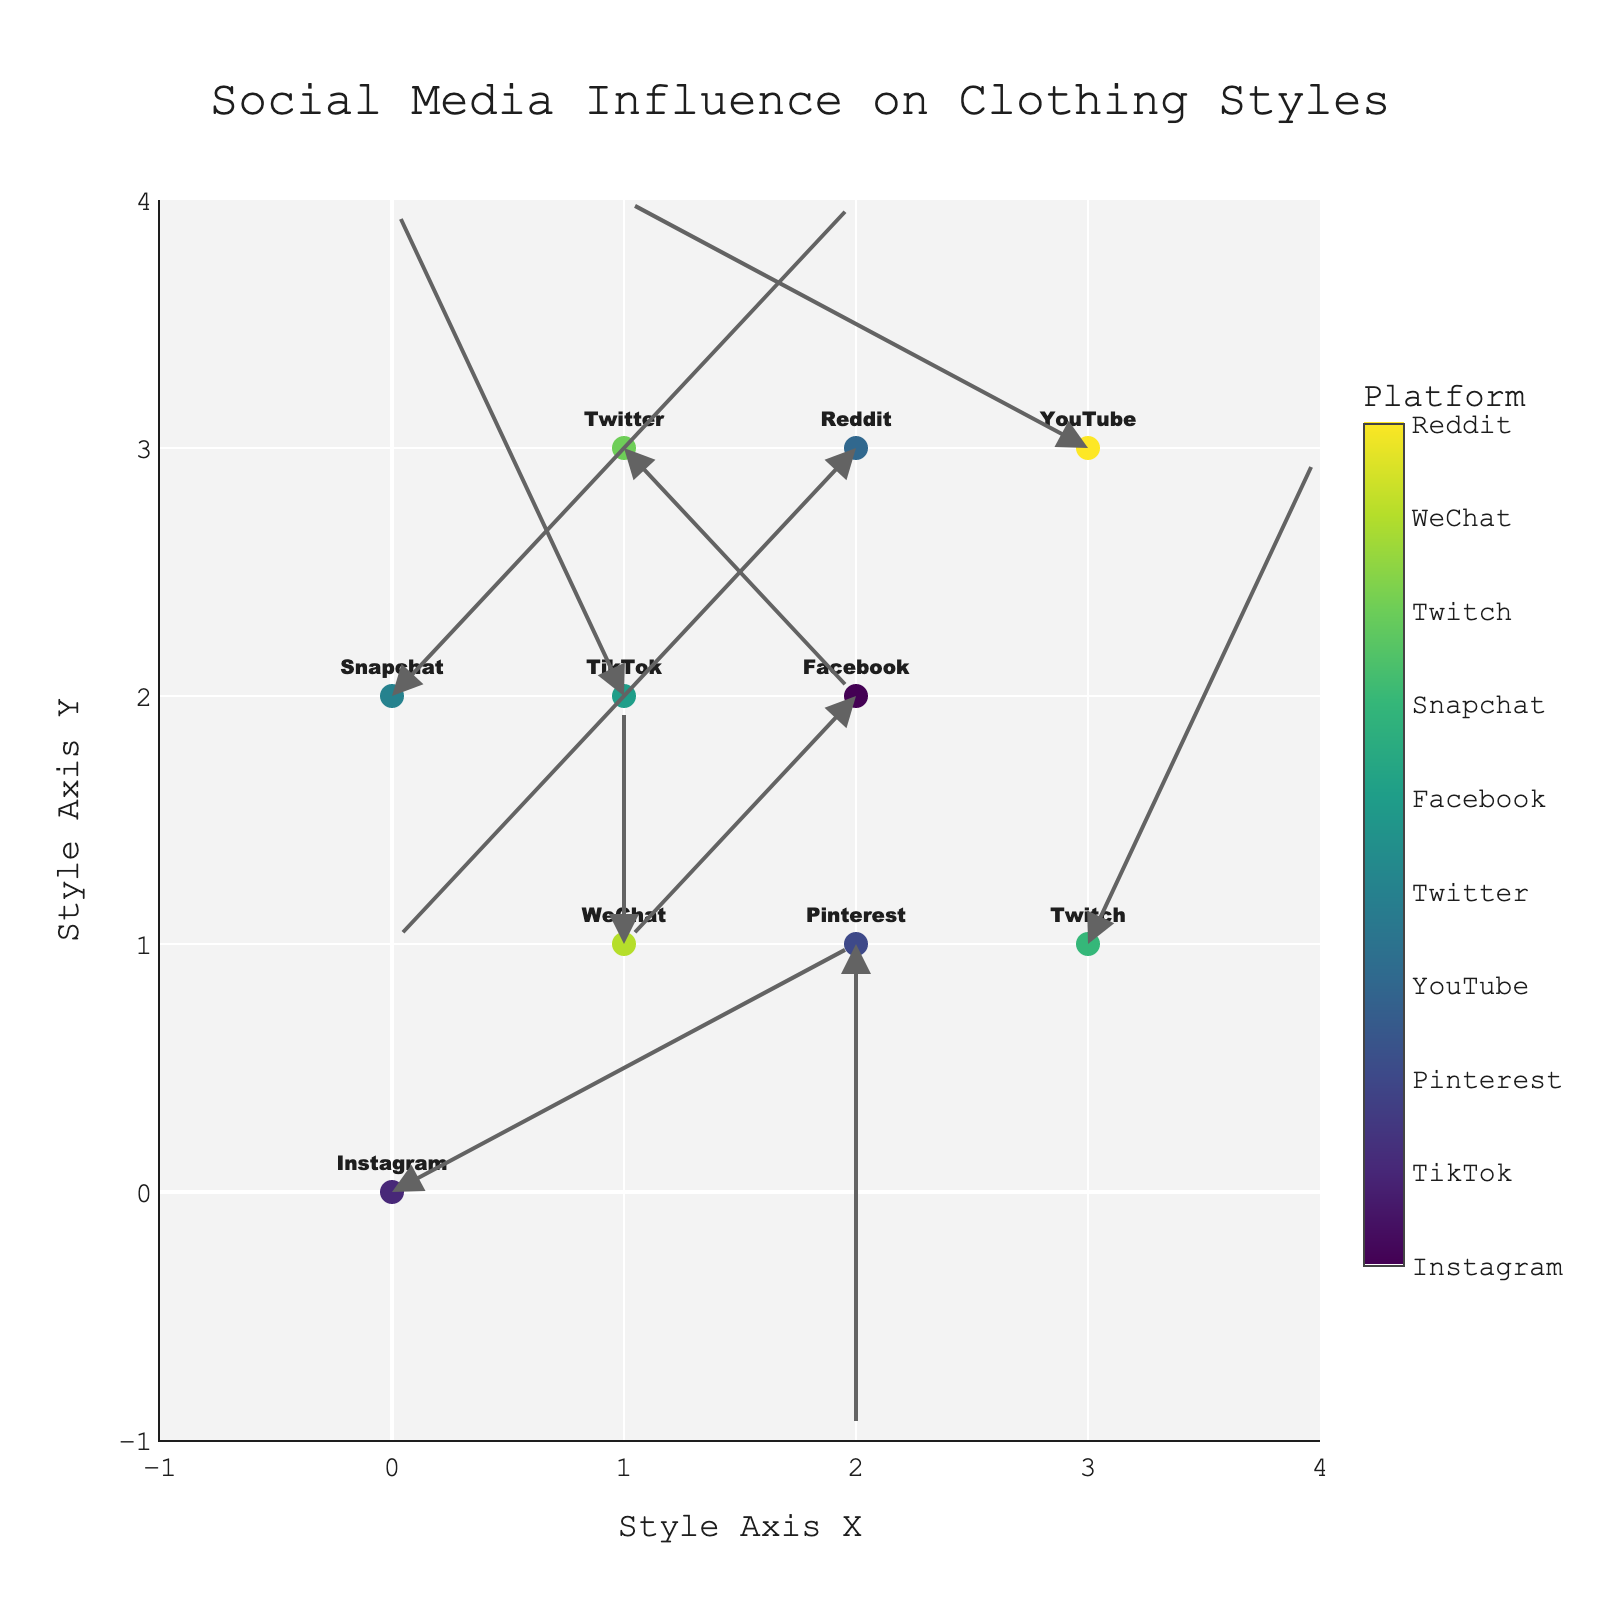Which platform is positioned at (0,0) on the plot? By looking at the figure, the point located at (0,0) with a marker should have the text "Instagram" next to it.
Answer: Instagram Which platform has an influence directing towards (3,4)? To find this, locate an arrow that starts from (2, 3) and has a direction vector (1, 1), which would end at (3, 4). The platform at (2, 3) with such an arrow is Pinterest.
Answer: Pinterest Which platforms influence fashion styles towards increasing both x and y coordinates? Look for arrows that point up and to the right. In the figure, the platforms with arrows pointing in the (u > 0, v > 0) direction are Snapchat at (0,2) and Twitch at (3,1).
Answer: Snapchat, Twitch Which platform pushes fashion styles the most horizontally to the left? The arrows representing influence directed horizontally to the left will have the largest negative u values. The platform with the arrow having the u value of -2 is YouTube at (3, 3).
Answer: YouTube Which platform's influence creates the most vertical downward shift? Check the arrows pointing directly downward that have the largest negative v values. The downward arrow with the largest negative v of -2 is Pinterest at (2,1).
Answer: Pinterest Comparing Twitter and Reddit, which has an influence vector with a greater Euclidean magnitude? Calculate the magnitudes: Twitter's vector (1, -1) has a magnitude sqrt(1^2 + (-1)^2) = sqrt(2). Reddit's vector (-2, -2) has a magnitude sqrt((-2)^2 + (-2)^2) = sqrt(8). Reddit's influence vector is greater.
Answer: Reddit Which platform's influence has no horizontal impact on fashion styles? Identify arrows with u = 0. In the plot, platforms with no horizontal movement are WeChat at (1,1) and Pinterest at (2,1).
Answer: WeChat, Pinterest What is the general trend direction of TikTok's influence on fashion styles? For TikTok, the arrow begins at (1,2) and points to (-1,2). This means that TikTok's influence shifts fashion styles downward in the x direction.
Answer: Downward x direction Which platform has its influence vector directing to the coordinates (2,0)? Find a platform where its arrow would point to (2,0). The only coordinate that fits this is from (2,2) pointing with (-1,-1), which is Facebook.
Answer: Facebook 